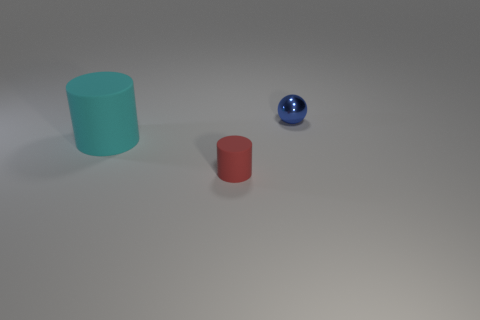Add 2 tiny red cubes. How many objects exist? 5 Subtract all cylinders. How many objects are left? 1 Subtract all large green rubber blocks. Subtract all large cyan matte things. How many objects are left? 2 Add 2 tiny metallic objects. How many tiny metallic objects are left? 3 Add 1 blue metallic things. How many blue metallic things exist? 2 Subtract 0 cyan balls. How many objects are left? 3 